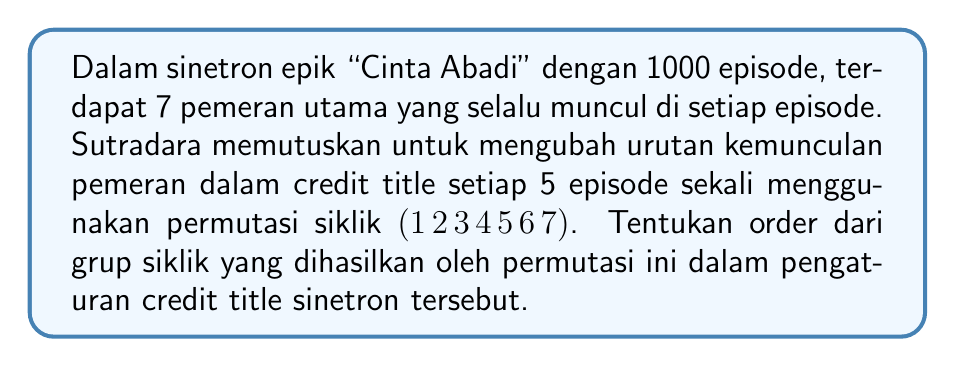Can you solve this math problem? Untuk menyelesaikan masalah ini, kita perlu memahami beberapa konsep dalam teori grup:

1. Permutasi siklik $(1 \, 2 \, 3 \, 4 \, 5 \, 6 \, 7)$ berarti elemen 1 dipindahkan ke posisi 2, 2 ke 3, dan seterusnya, dengan 7 kembali ke posisi 1.

2. Order dari sebuah elemen dalam grup adalah bilangan bulat positif terkecil $n$ di mana $a^n = e$ (elemen identitas).

3. Untuk permutasi siklik dengan panjang $k$, order-nya adalah $k$ itu sendiri.

Dalam kasus ini:

1. Permutasi siklik memiliki panjang 7.
2. Maka, order dari permutasi ini adalah 7.
3. Ini berarti setelah 7 kali penerapan permutasi, kita akan kembali ke susunan awal.

Untuk memverifikasi:
$$(1 \, 2 \, 3 \, 4 \, 5 \, 6 \, 7)^1 = (1 \, 2 \, 3 \, 4 \, 5 \, 6 \, 7)$$
$$(1 \, 2 \, 3 \, 4 \, 5 \, 6 \, 7)^2 = (1 \, 3 \, 5 \, 7 \, 2 \, 4 \, 6)$$
$$(1 \, 2 \, 3 \, 4 \, 5 \, 6 \, 7)^3 = (1 \, 4 \, 7 \, 3 \, 6 \, 2 \, 5)$$
$$(1 \, 2 \, 3 \, 4 \, 5 \, 6 \, 7)^4 = (1 \, 5 \, 2 \, 6 \, 3 \, 7 \, 4)$$
$$(1 \, 2 \, 3 \, 4 \, 5 \, 6 \, 7)^5 = (1 \, 6 \, 4 \, 2 \, 7 \, 5 \, 3)$$
$$(1 \, 2 \, 3 \, 4 \, 5 \, 6 \, 7)^6 = (1 \, 7 \, 6 \, 5 \, 4 \, 3 \, 2)$$
$$(1 \, 2 \, 3 \, 4 \, 5 \, 6 \, 7)^7 = (1)$$

Jadi, grup siklik yang dihasilkan oleh permutasi ini memiliki order 7.
Answer: Order dari grup siklik yang dihasilkan oleh permutasi $(1 \, 2 \, 3 \, 4 \, 5 \, 6 \, 7)$ adalah 7. 